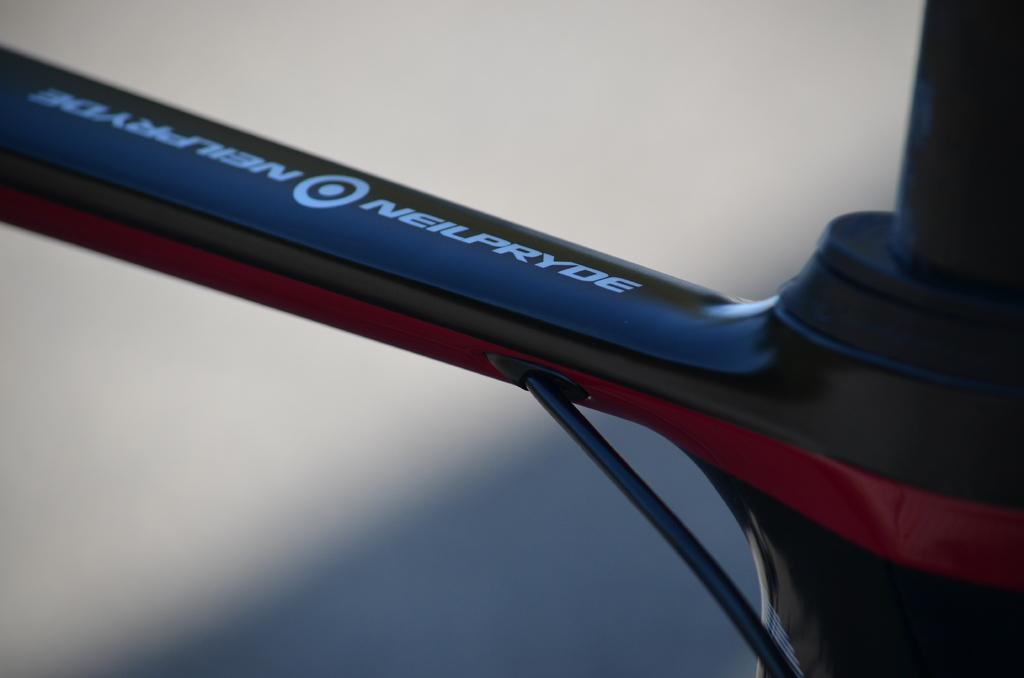What is the main subject of the image? There is an object in the image. What can be seen on the object? There is text on the object. Can you describe the background of the image? The background of the image is blurred. What type of wren can be seen perched on the lamp in the image? There is no wren or lamp present in the image; it only features an object with text and a blurred background. 